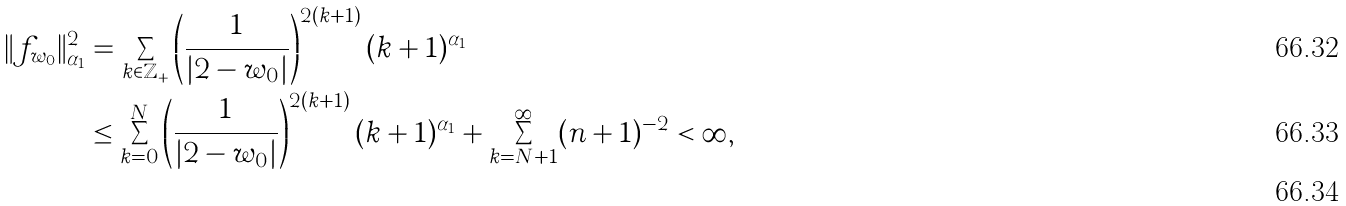Convert formula to latex. <formula><loc_0><loc_0><loc_500><loc_500>\| f _ { w _ { 0 } } \| _ { \alpha _ { 1 } } ^ { 2 } & = \sum _ { k \in \mathbb { Z } _ { + } } \left ( \frac { 1 } { | 2 - w _ { 0 } | } \right ) ^ { 2 ( k + 1 ) } ( k + 1 ) ^ { \alpha _ { 1 } } \\ & \leq \sum _ { k = 0 } ^ { N } \left ( \frac { 1 } { | 2 - w _ { 0 } | } \right ) ^ { 2 ( k + 1 ) } ( k + 1 ) ^ { \alpha _ { 1 } } + \sum _ { k = N + 1 } ^ { \infty } ( n + 1 ) ^ { - 2 } < \infty , \\</formula> 